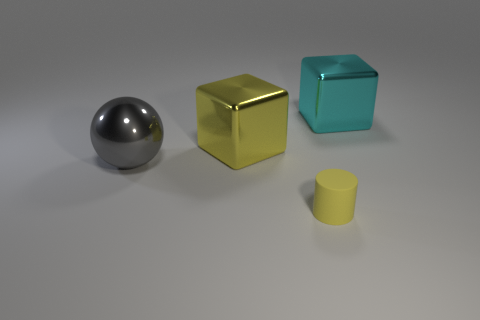Is the number of metallic cubes that are in front of the rubber cylinder greater than the number of blue rubber things?
Your answer should be compact. No. Does the yellow shiny thing have the same shape as the large thing that is on the left side of the big yellow thing?
Keep it short and to the point. No. Are there any tiny yellow things?
Your response must be concise. Yes. How many small objects are brown shiny cylinders or cyan blocks?
Offer a very short reply. 0. Is the number of large cubes that are in front of the tiny yellow thing greater than the number of tiny yellow cylinders that are behind the sphere?
Give a very brief answer. No. Is the material of the sphere the same as the yellow thing that is behind the big gray metallic thing?
Offer a very short reply. Yes. What color is the rubber cylinder?
Ensure brevity in your answer.  Yellow. There is a yellow thing behind the yellow rubber cylinder; what shape is it?
Give a very brief answer. Cube. How many blue objects are either balls or shiny objects?
Offer a very short reply. 0. What is the color of the other block that is the same material as the big cyan block?
Offer a terse response. Yellow. 